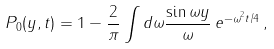Convert formula to latex. <formula><loc_0><loc_0><loc_500><loc_500>P _ { 0 } ( y , { t } ) = 1 - \frac { 2 } { \pi } \int d \omega \frac { \sin \omega y } { \omega } \, e ^ { - \omega ^ { 2 } { t } / 4 } \, ,</formula> 